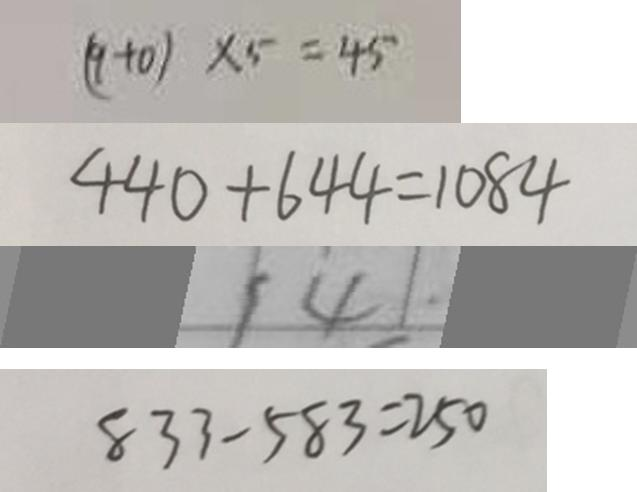<formula> <loc_0><loc_0><loc_500><loc_500>( 9 + 0 ) \times 5 = 4 5 
 4 4 0 + 6 4 4 = 1 0 8 4 
 1 4 \cdot 
 8 3 3 - 5 8 3 = 2 5 0</formula> 